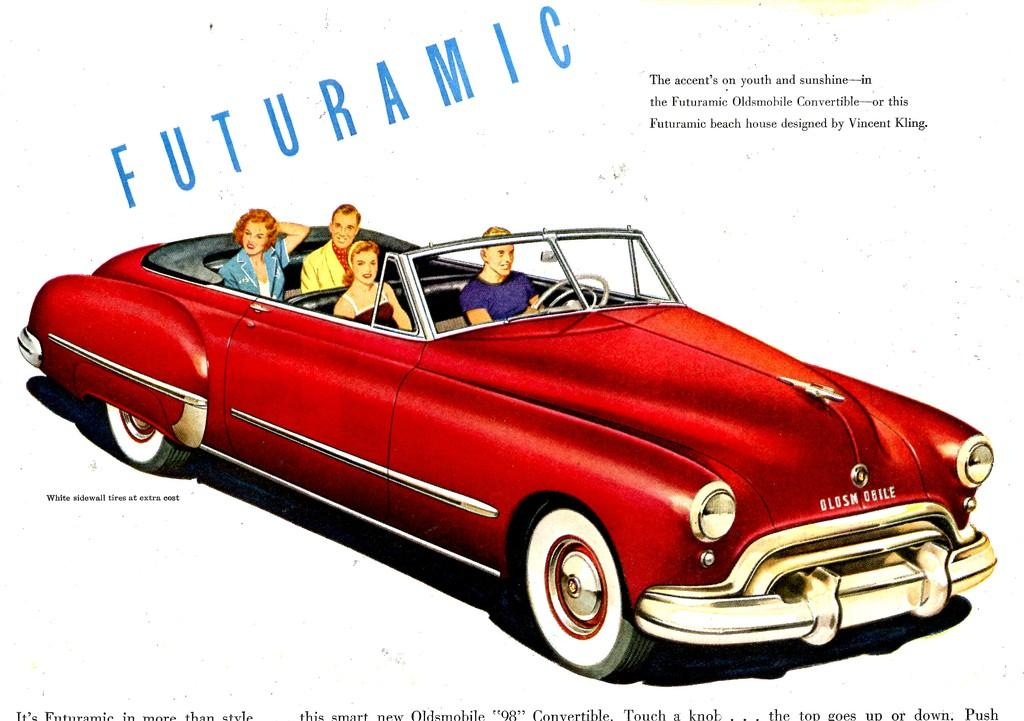What is featured on the poster in the image? The facts provided do not specify the content of the poster. What type of vehicle can be seen in the image? There are people riding a red car in the image. What else is visible in the image besides the poster and the car? There is text visible in the image. How many spots can be seen on the cow in the image? There is no cow present in the image. What arithmetic problem is being solved on the poster in the image? The facts provided do not specify any arithmetic problem on the poster. 